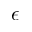Convert formula to latex. <formula><loc_0><loc_0><loc_500><loc_500>\epsilon</formula> 